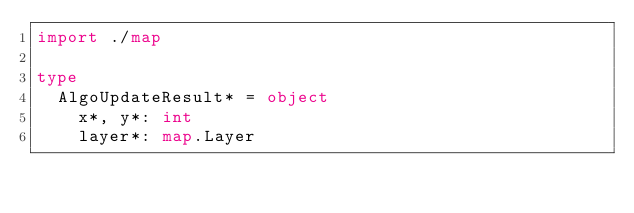<code> <loc_0><loc_0><loc_500><loc_500><_Nim_>import ./map

type
  AlgoUpdateResult* = object
    x*, y*: int
    layer*: map.Layer
</code> 